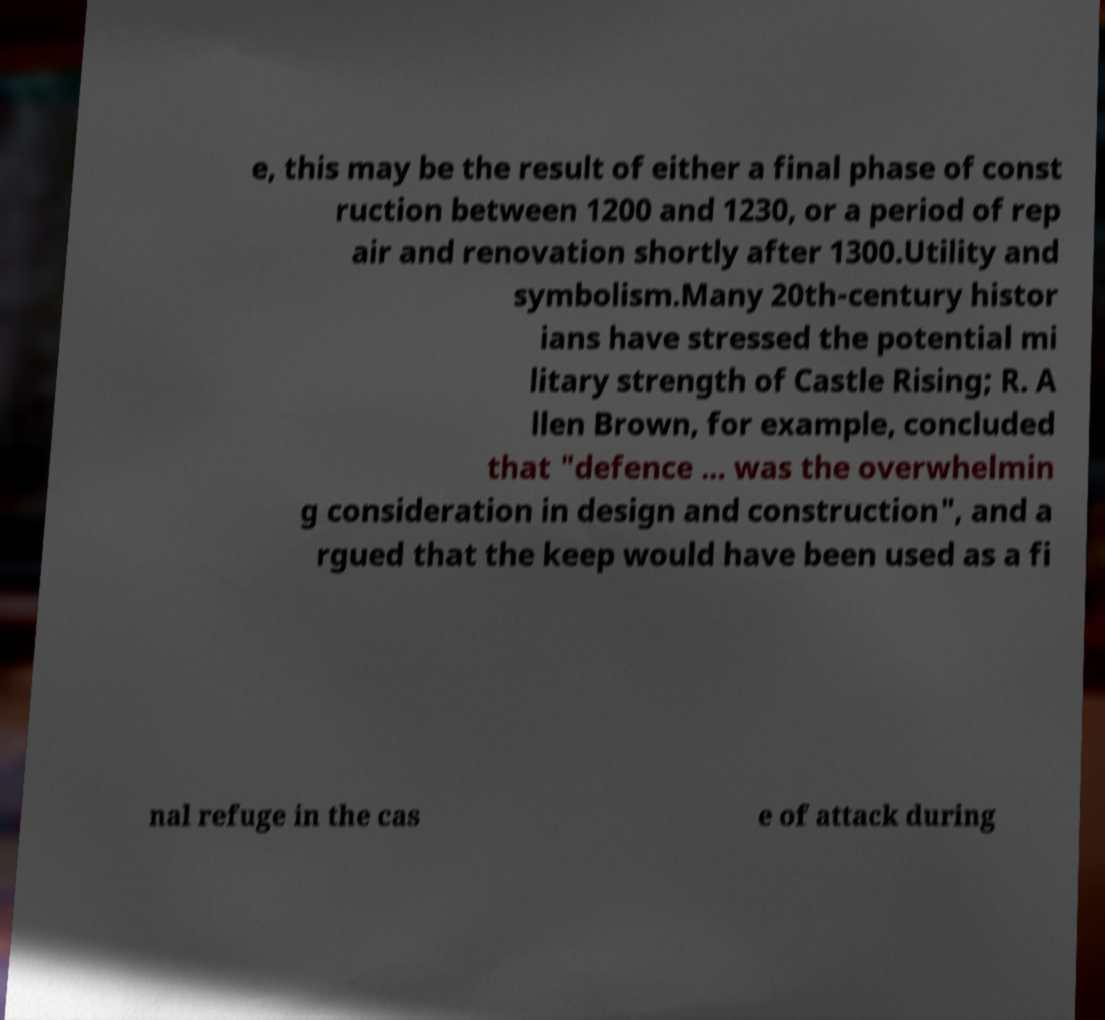Could you assist in decoding the text presented in this image and type it out clearly? e, this may be the result of either a final phase of const ruction between 1200 and 1230, or a period of rep air and renovation shortly after 1300.Utility and symbolism.Many 20th-century histor ians have stressed the potential mi litary strength of Castle Rising; R. A llen Brown, for example, concluded that "defence ... was the overwhelmin g consideration in design and construction", and a rgued that the keep would have been used as a fi nal refuge in the cas e of attack during 